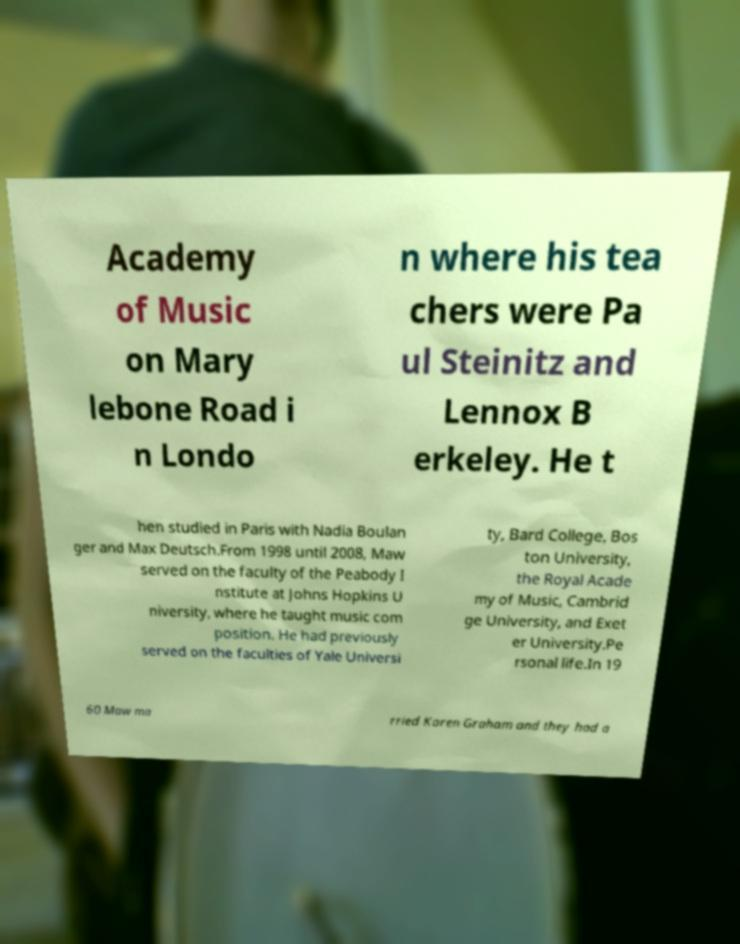Please identify and transcribe the text found in this image. Academy of Music on Mary lebone Road i n Londo n where his tea chers were Pa ul Steinitz and Lennox B erkeley. He t hen studied in Paris with Nadia Boulan ger and Max Deutsch.From 1998 until 2008, Maw served on the faculty of the Peabody I nstitute at Johns Hopkins U niversity, where he taught music com position. He had previously served on the faculties of Yale Universi ty, Bard College, Bos ton University, the Royal Acade my of Music, Cambrid ge University, and Exet er University.Pe rsonal life.In 19 60 Maw ma rried Karen Graham and they had a 